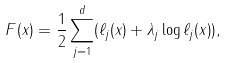Convert formula to latex. <formula><loc_0><loc_0><loc_500><loc_500>F ( x ) = \frac { 1 } { 2 } \sum _ { j = 1 } ^ { d } ( \ell _ { j } ( x ) + \lambda _ { j } \log { \ell _ { j } ( x ) } ) ,</formula> 